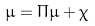Convert formula to latex. <formula><loc_0><loc_0><loc_500><loc_500>\mu = \Pi \mu + \chi</formula> 